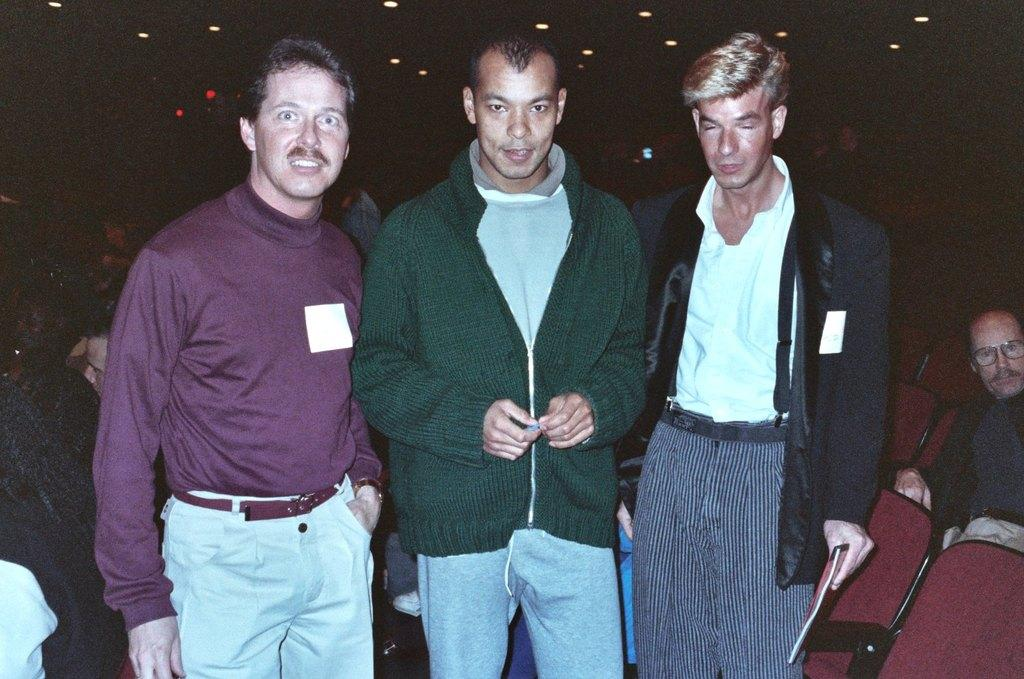How many people are present in the image? There are three people in the image. What can be seen in the background of the image? There are chairs, other people, and lights in the background of the image. What is one person doing in the image? One person is holding a book. What type of jewel is the person wearing on their head in the image? There is no jewel visible on anyone's head in the image. How does the person pull the book towards them in the image? The person is not pulling the book towards them in the image; they are simply holding it. 